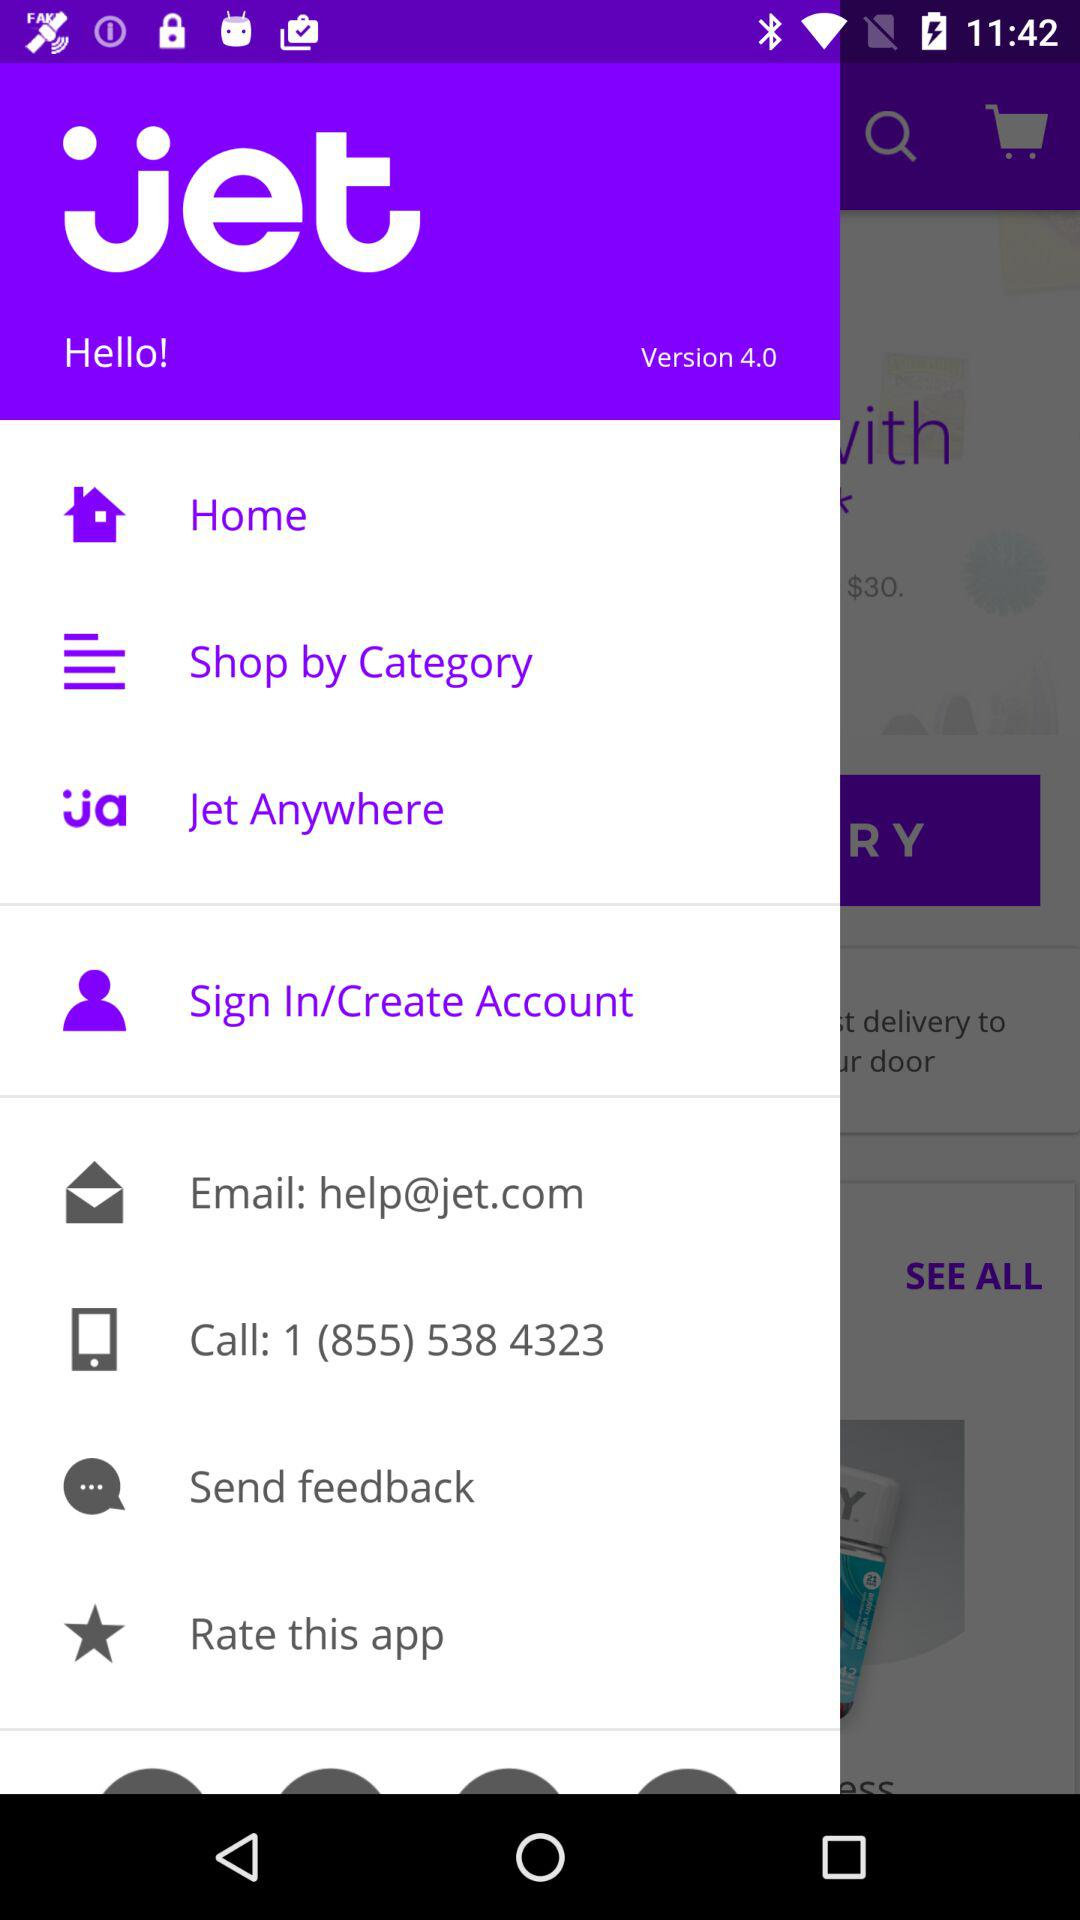How many stars does the application have?
When the provided information is insufficient, respond with <no answer>. <no answer> 